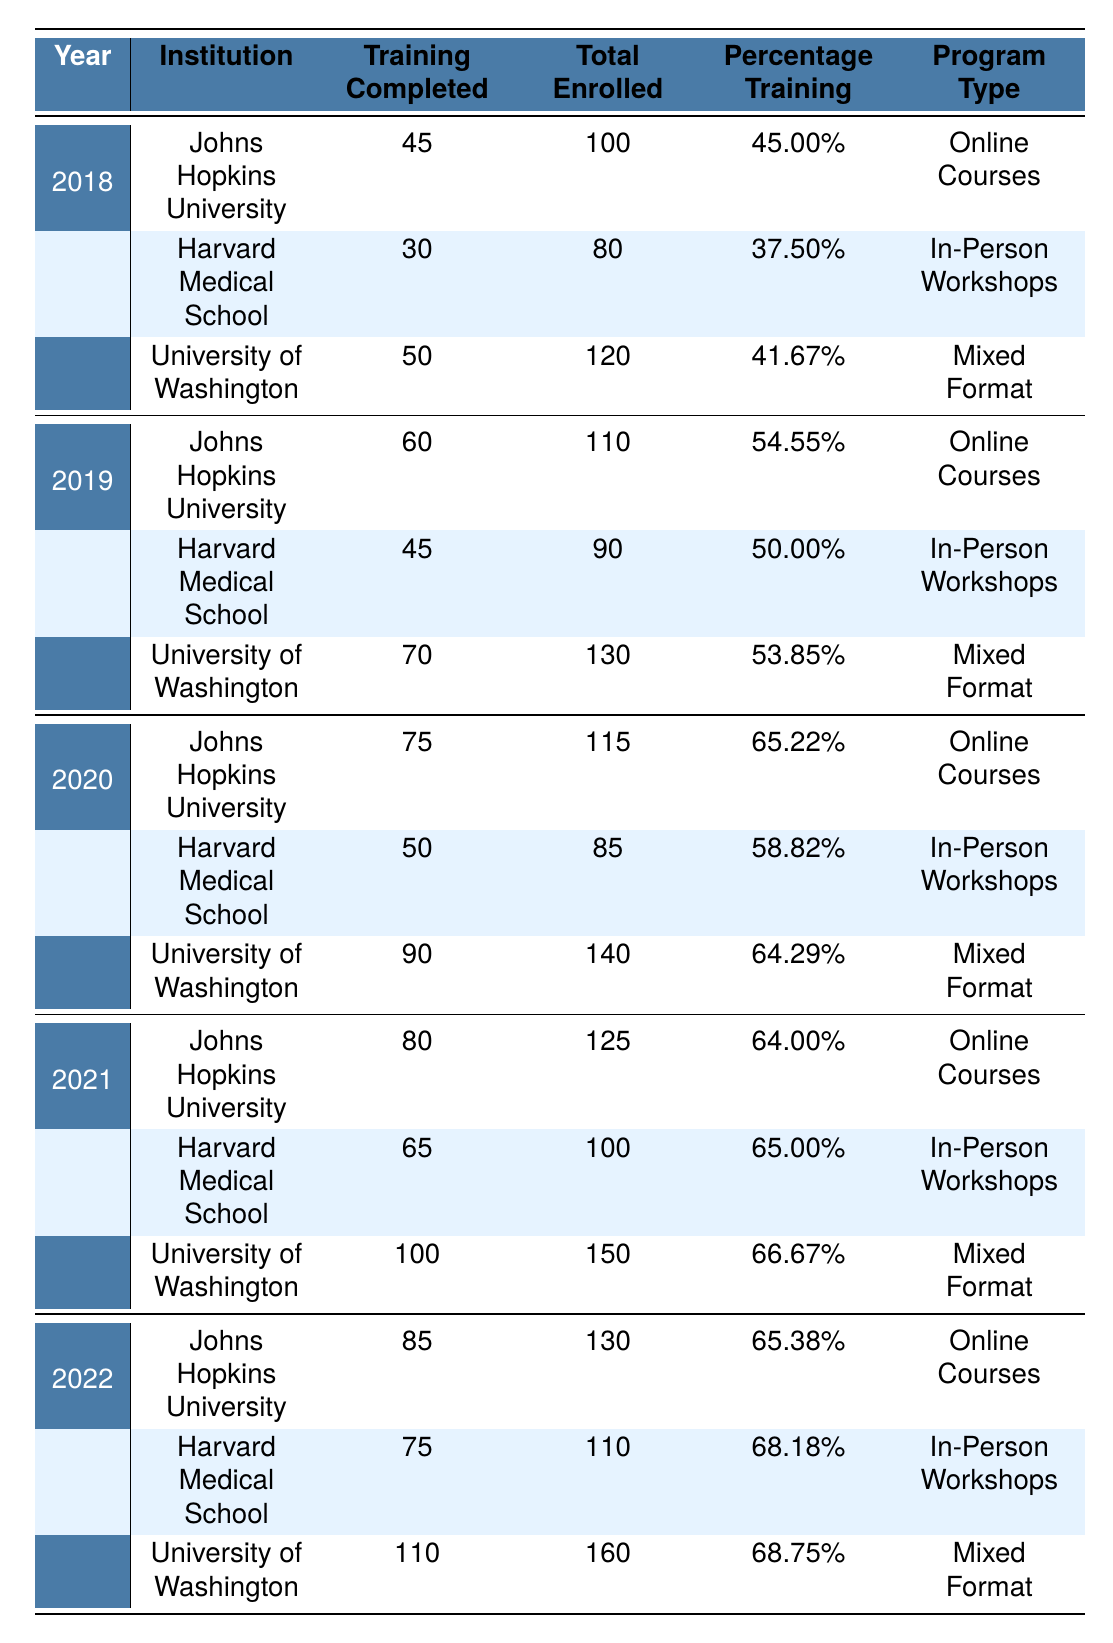What institution had the highest training completion in 2022? In 2022, the training completed values for the institutions are: Johns Hopkins University (85), Harvard Medical School (75), and University of Washington (110). Among these, University of Washington has the highest value of 110.
Answer: University of Washington What was the percentage of training completed by Harvard Medical School in 2019? The table shows that in 2019, Harvard Medical School had a percentage training of 50%.
Answer: 50% Which institution had the highest percentage training in 2021? In 2021, the percentage training values are: Johns Hopkins University (64%), Harvard Medical School (65%), and University of Washington (66.67%). The highest percentage is from University of Washington at 66.67%.
Answer: University of Washington How much did training completion increase at Johns Hopkins University from 2018 to 2022? The training completed values for Johns Hopkins University are: 45 in 2018 and 85 in 2022. The increase is calculated as 85 - 45 = 40.
Answer: 40 What was the total number of individuals trained across all institutions in 2020? The total training completed in 2020 is the sum of training completed values from all institutions: Johns Hopkins University (75) + Harvard Medical School (50) + University of Washington (90) = 215.
Answer: 215 Was the percentage of training completed at Harvard Medical School consistently higher than 50% from 2018 to 2022? In the years provided, the percentage training for Harvard Medical School was: 37.5% in 2018, 50% in 2019, 58.82% in 2020, 65% in 2021, and 68.18% in 2022. The percentage was below 50% in 2018, so it was not consistent.
Answer: No What is the average percentage training completed for all institutions in 2020? The percentage training values for 2020 are: Johns Hopkins University (65.22%), Harvard Medical School (58.82%), University of Washington (64.29%). The average is calculated as (65.22 + 58.82 + 64.29) / 3 = 62.44.
Answer: 62.44 Which institution showed the largest increase in training completion from 2018 to 2021? The increases in training completion are: Johns Hopkins University (45 to 80), Harvard Medical School (30 to 65), and University of Washington (50 to 100). The increases are 35, 35, and 50 respectively. University of Washington had the largest increase of 50.
Answer: University of Washington How many individuals completed training at the University of Washington in 2019? The training completed at the University of Washington in 2019 was 70 individuals as shown in the table.
Answer: 70 What was the total enrollment for Johns Hopkins University across all years? The total enrollment for Johns Hopkins University is calculated by summing up the total enrolled values: 100 (2018) + 110 (2019) + 115 (2020) + 125 (2021) + 130 (2022) = 580.
Answer: 580 Did any institution achieve a training completion percentage above 68% in 2022? In 2022, the percentages for each institution were: Johns Hopkins University (65.38%), Harvard Medical School (68.18%), and University of Washington (68.75%). Since University of Washington had 68.75%, which is above 68%, the answer is yes.
Answer: Yes 